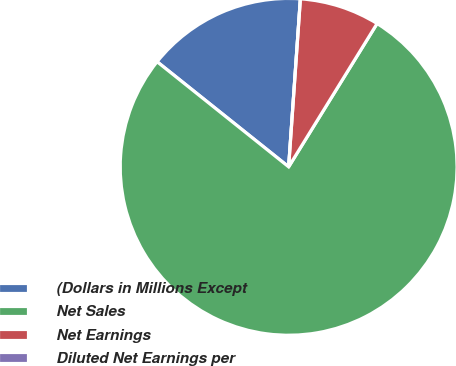Convert chart to OTSL. <chart><loc_0><loc_0><loc_500><loc_500><pie_chart><fcel>(Dollars in Millions Except<fcel>Net Sales<fcel>Net Earnings<fcel>Diluted Net Earnings per<nl><fcel>15.38%<fcel>76.92%<fcel>7.69%<fcel>0.0%<nl></chart> 